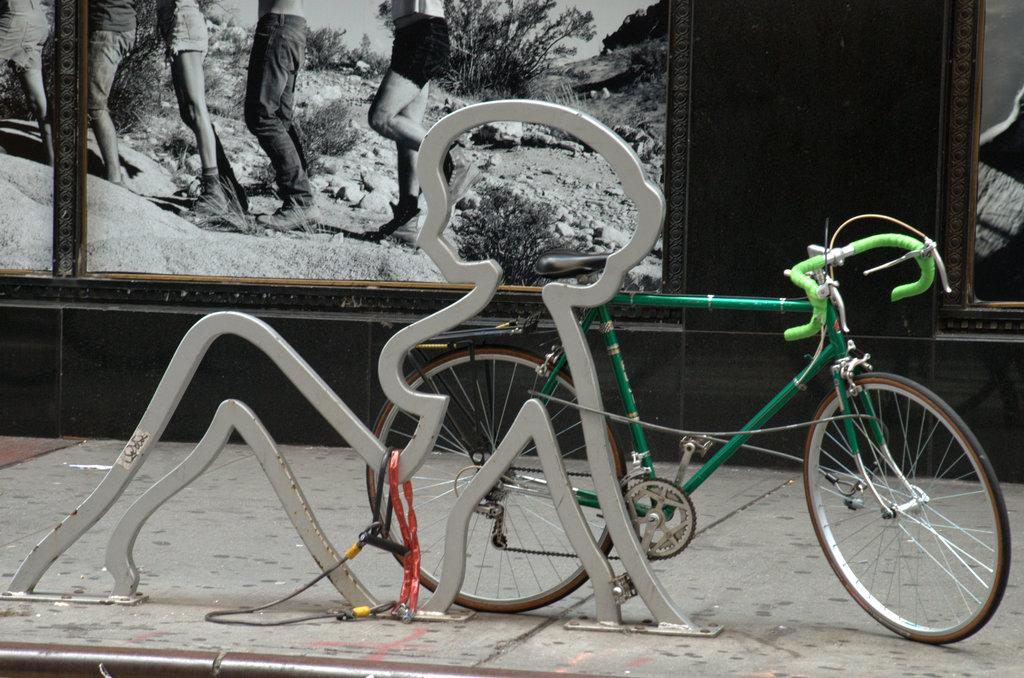What is the main object in the center of the image? There is a bicycle in the center of the image. What type of structure is present in the image? An iron frame is present in the image. What is located at the top of the image? There is a photo frame at the top of the image. What can be seen at the bottom of the image? The ground is visible at the bottom of the image. What type of nerve is visible in the image? There is no nerve present in the image. How does the form of the bicycle change throughout the image? The form of the bicycle does not change throughout the image; it remains the same central object. 